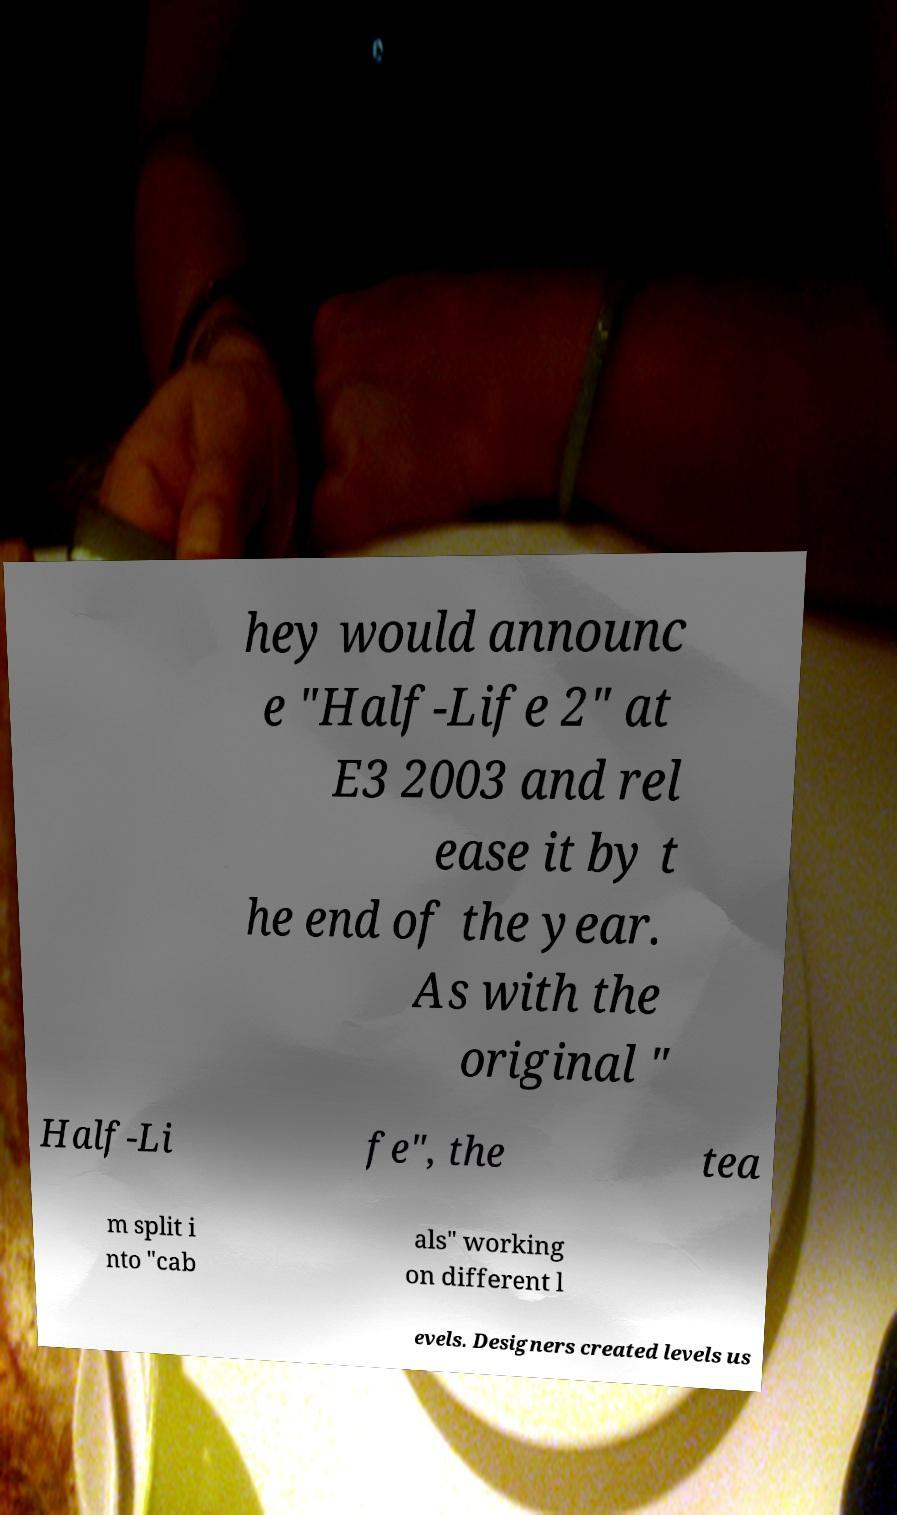Could you extract and type out the text from this image? hey would announc e "Half-Life 2" at E3 2003 and rel ease it by t he end of the year. As with the original " Half-Li fe", the tea m split i nto "cab als" working on different l evels. Designers created levels us 